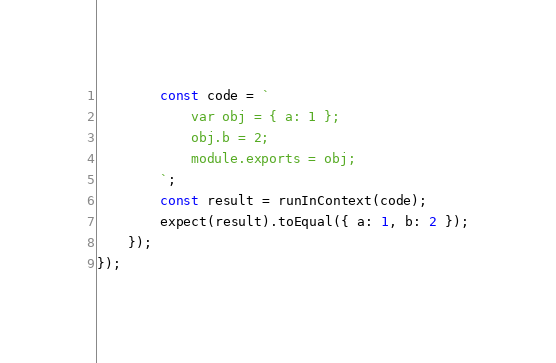Convert code to text. <code><loc_0><loc_0><loc_500><loc_500><_TypeScript_>        const code = `
            var obj = { a: 1 };
            obj.b = 2;
            module.exports = obj;
        `;
        const result = runInContext(code);
        expect(result).toEqual({ a: 1, b: 2 });
    });
});</code> 